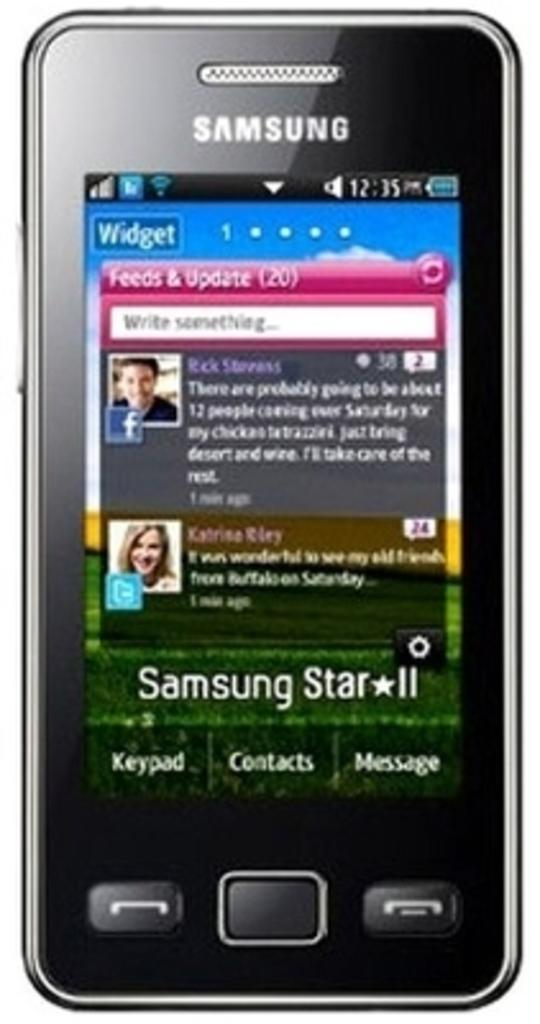Provide a one-sentence caption for the provided image. A Samsung smart phone that shows it to be 12:35. 